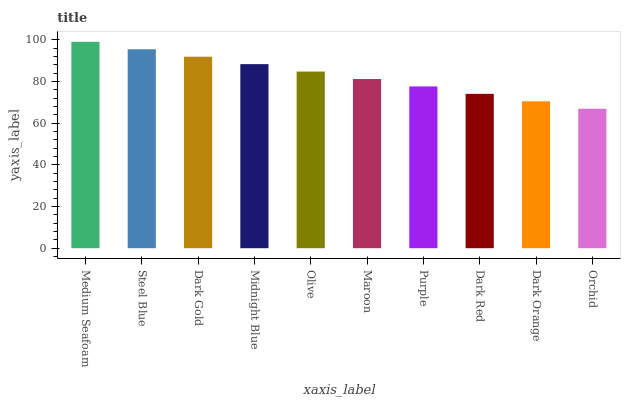Is Orchid the minimum?
Answer yes or no. Yes. Is Medium Seafoam the maximum?
Answer yes or no. Yes. Is Steel Blue the minimum?
Answer yes or no. No. Is Steel Blue the maximum?
Answer yes or no. No. Is Medium Seafoam greater than Steel Blue?
Answer yes or no. Yes. Is Steel Blue less than Medium Seafoam?
Answer yes or no. Yes. Is Steel Blue greater than Medium Seafoam?
Answer yes or no. No. Is Medium Seafoam less than Steel Blue?
Answer yes or no. No. Is Olive the high median?
Answer yes or no. Yes. Is Maroon the low median?
Answer yes or no. Yes. Is Midnight Blue the high median?
Answer yes or no. No. Is Midnight Blue the low median?
Answer yes or no. No. 